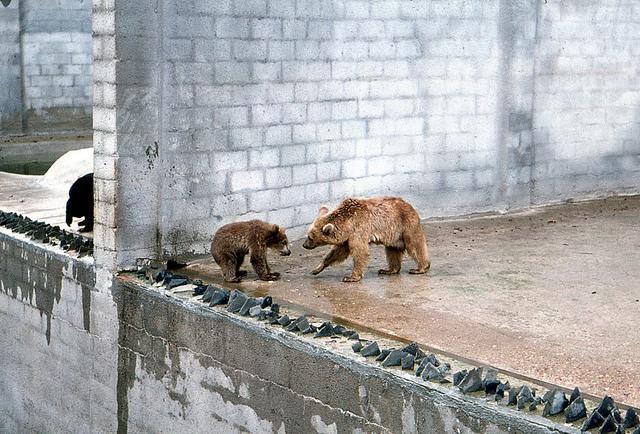How many bears can be seen?
Give a very brief answer. 2. 